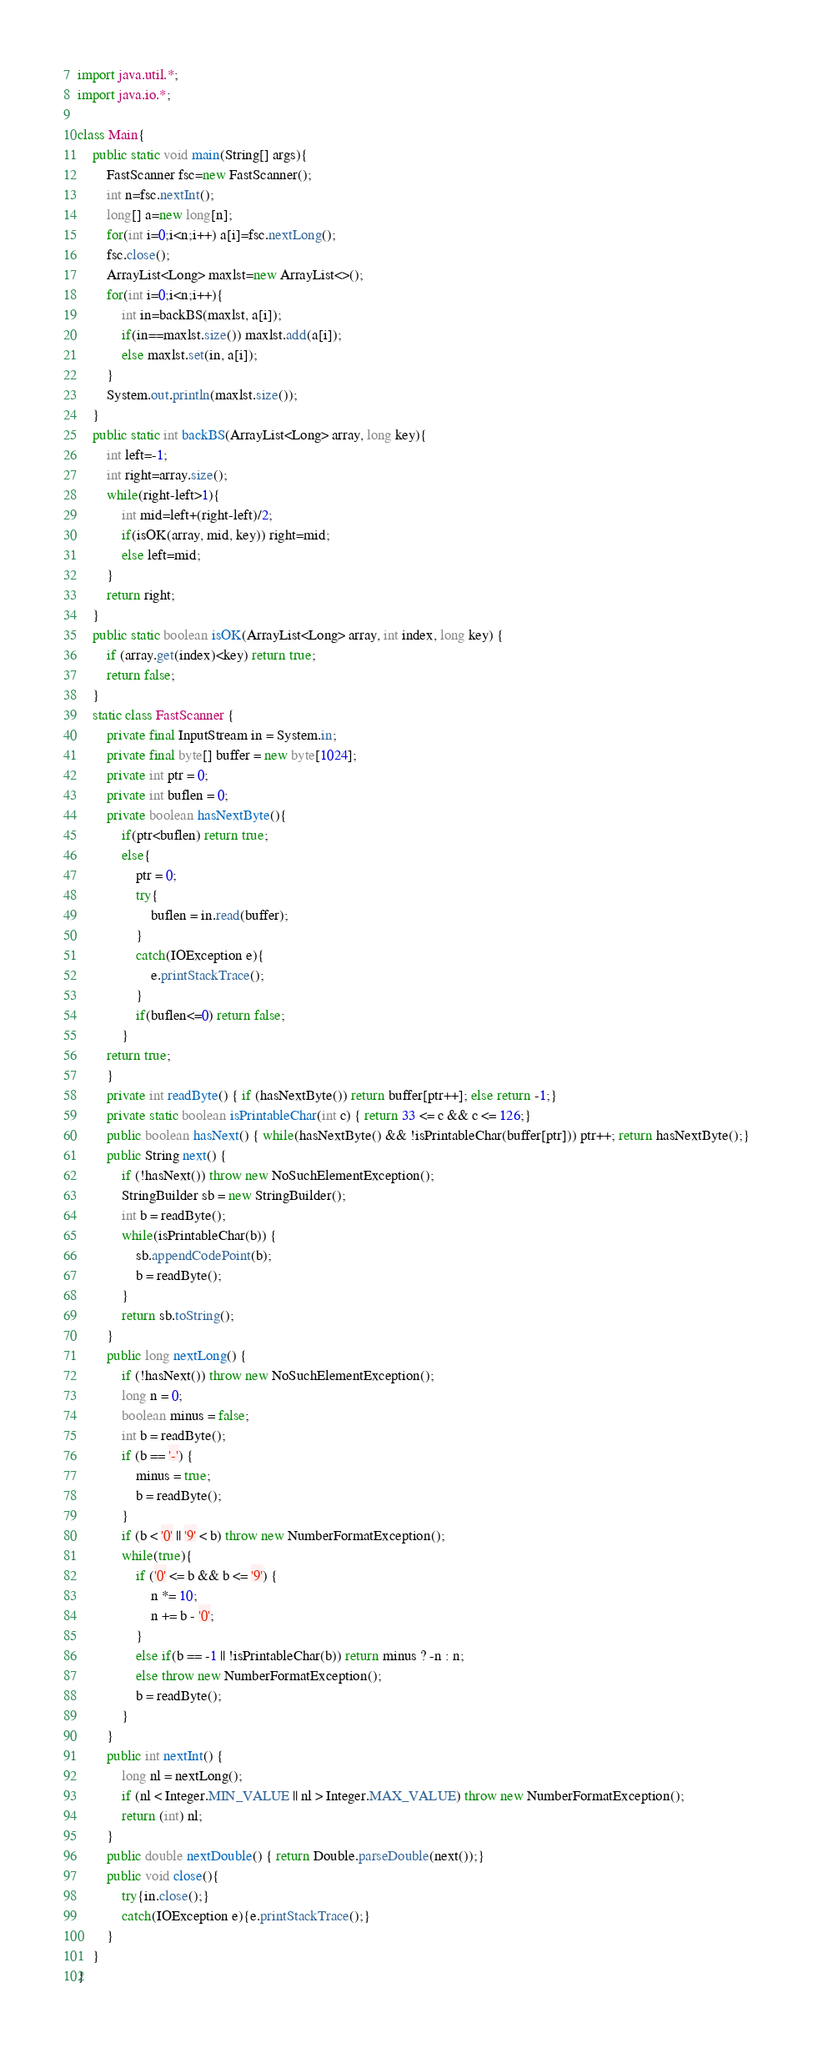Convert code to text. <code><loc_0><loc_0><loc_500><loc_500><_Java_>import java.util.*;
import java.io.*;

class Main{
    public static void main(String[] args){
        FastScanner fsc=new FastScanner();
        int n=fsc.nextInt();
        long[] a=new long[n];
        for(int i=0;i<n;i++) a[i]=fsc.nextLong();
        fsc.close();
        ArrayList<Long> maxlst=new ArrayList<>();
        for(int i=0;i<n;i++){
            int in=backBS(maxlst, a[i]);
            if(in==maxlst.size()) maxlst.add(a[i]);
            else maxlst.set(in, a[i]);
        }
        System.out.println(maxlst.size());
    }
    public static int backBS(ArrayList<Long> array, long key){
        int left=-1;
        int right=array.size();
        while(right-left>1){
            int mid=left+(right-left)/2;
            if(isOK(array, mid, key)) right=mid;
            else left=mid;
        }
        return right;
    }
    public static boolean isOK(ArrayList<Long> array, int index, long key) {
        if (array.get(index)<key) return true;
        return false;
    }
    static class FastScanner {
        private final InputStream in = System.in;
        private final byte[] buffer = new byte[1024];
        private int ptr = 0;
        private int buflen = 0;
        private boolean hasNextByte(){
            if(ptr<buflen) return true;
            else{
                ptr = 0;
                try{
                    buflen = in.read(buffer);
                }
                catch(IOException e){
                    e.printStackTrace();
                }
                if(buflen<=0) return false;
            }
        return true;
        }
        private int readByte() { if (hasNextByte()) return buffer[ptr++]; else return -1;}
        private static boolean isPrintableChar(int c) { return 33 <= c && c <= 126;}
        public boolean hasNext() { while(hasNextByte() && !isPrintableChar(buffer[ptr])) ptr++; return hasNextByte();}
        public String next() {
            if (!hasNext()) throw new NoSuchElementException();
            StringBuilder sb = new StringBuilder();
            int b = readByte();
            while(isPrintableChar(b)) {
                sb.appendCodePoint(b);
                b = readByte();
            }
            return sb.toString();
        }
        public long nextLong() {
            if (!hasNext()) throw new NoSuchElementException();
            long n = 0;
            boolean minus = false;
            int b = readByte();
            if (b == '-') {
                minus = true;
                b = readByte();
            }
            if (b < '0' || '9' < b) throw new NumberFormatException();
            while(true){
                if ('0' <= b && b <= '9') {
                    n *= 10;
                    n += b - '0';
                }
                else if(b == -1 || !isPrintableChar(b)) return minus ? -n : n;
                else throw new NumberFormatException();
                b = readByte();
            }
        }
        public int nextInt() {
            long nl = nextLong();
            if (nl < Integer.MIN_VALUE || nl > Integer.MAX_VALUE) throw new NumberFormatException();
            return (int) nl;
        }
        public double nextDouble() { return Double.parseDouble(next());}
        public void close(){
            try{in.close();}
            catch(IOException e){e.printStackTrace();}
        }
    }
}</code> 